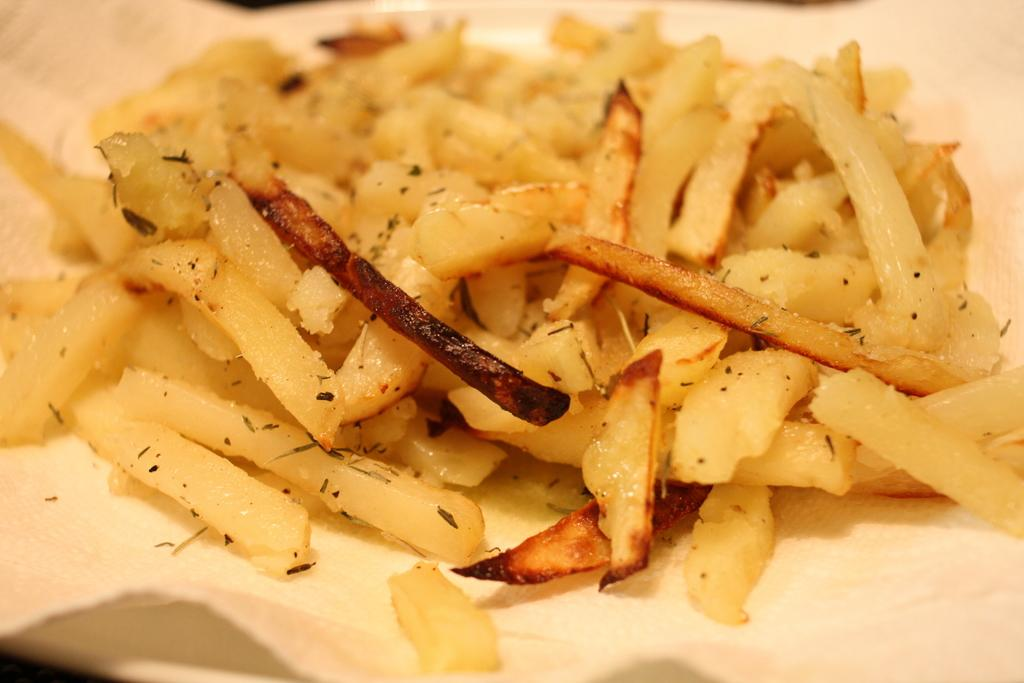What is present on the plate in the image? There is food in a plate in the image. What type of argument is taking place between the pies in the image? There are no pies present in the image, and therefore no argument can be observed. 